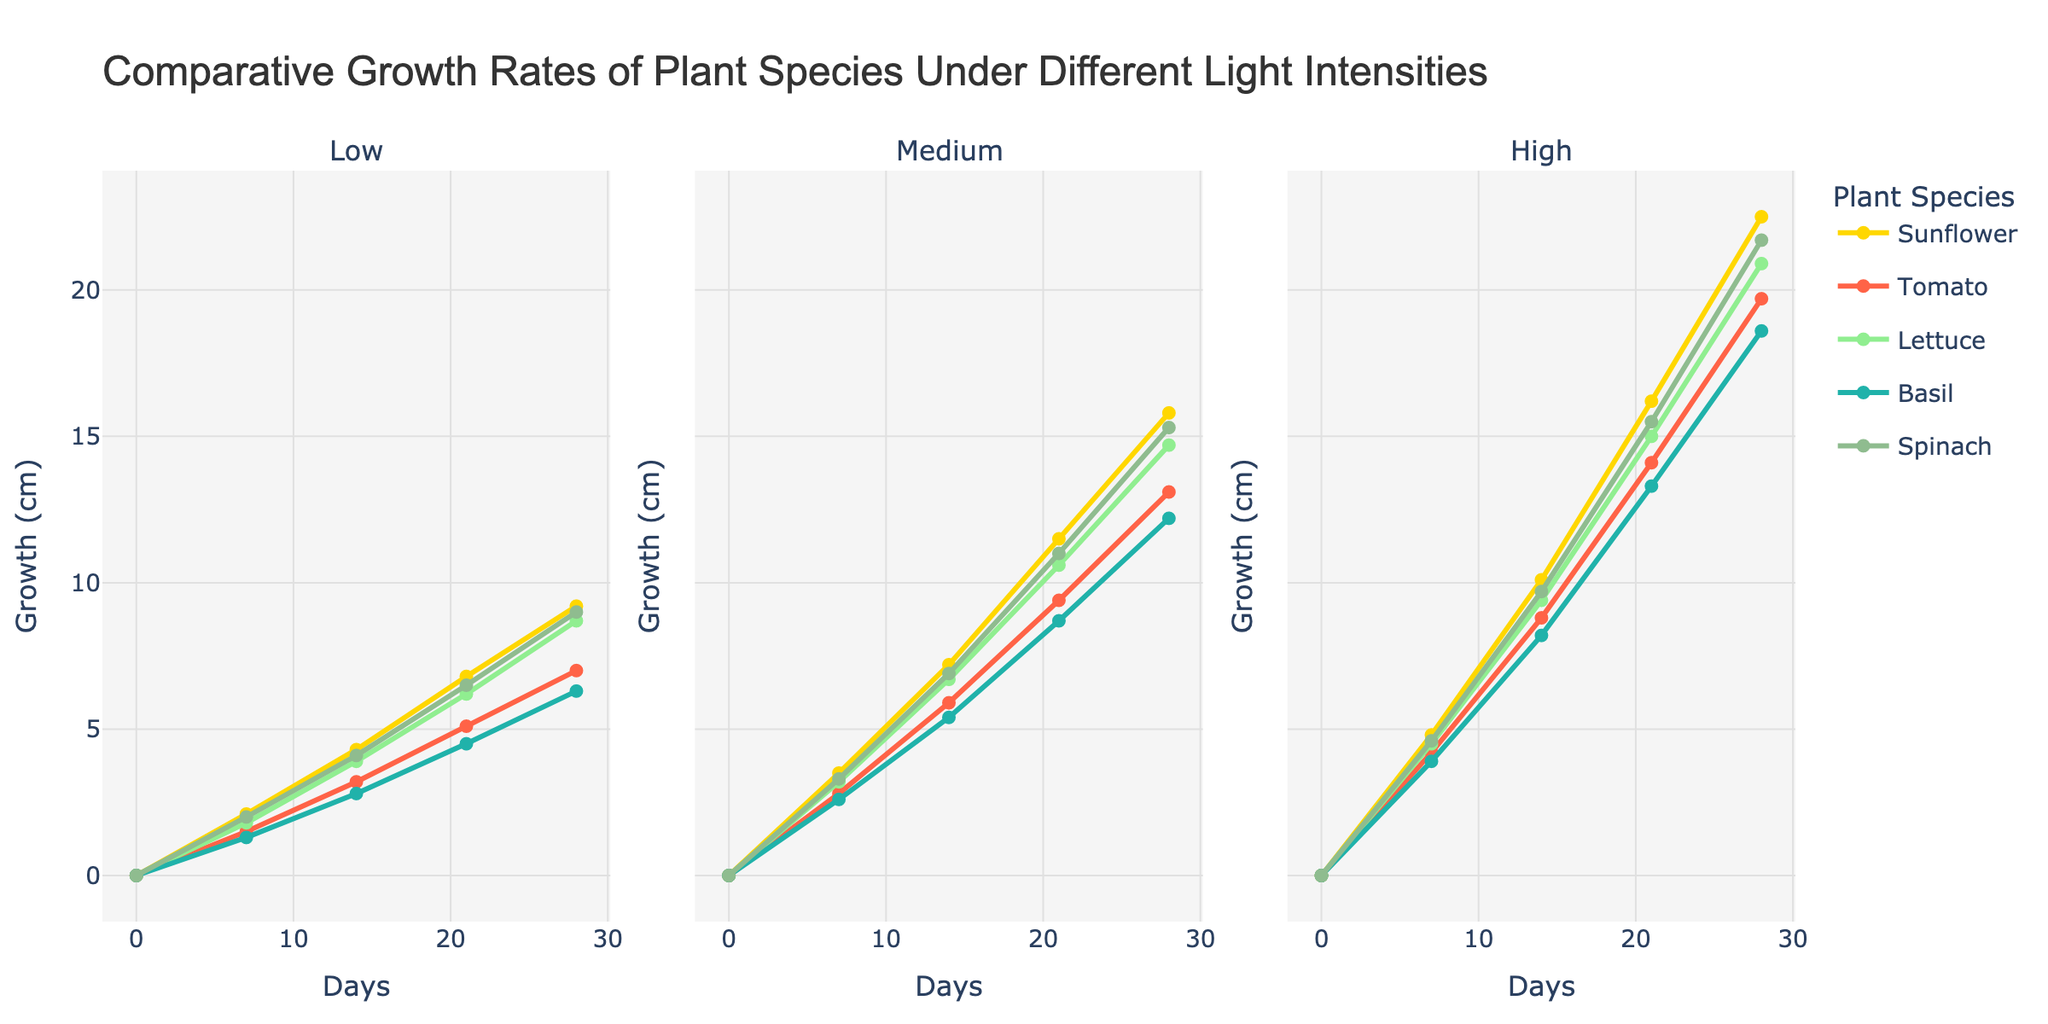which platform's post type 'Eco-Friendly Brand Collaboration' has the highest likes? Look at the 'Eco-Friendly Brand Collaboration' post type across all the platforms and compare the 'Likes' values. Pinterest has multiple data points, but we focus on the specific post type.
Answer: Instagram What is the total number of comments for Facebook posts? Sum up the 'Comments' for all Facebook posts. The values are 75, 58, 92, and 47: \(75 + 58 + 92 + 47 = 272\).
Answer: 272 Which platform has the least number of shares for 'Recycled Packaging Initiative'? Look specifically at the 'Recycled Packaging Initiative' post type across all platforms and compare the 'Shares' values.
Answer: Instagram On which platform does the 'Green Fashion Week Coverage' post type appear, and what are its engagement metrics? Identify the platform displaying 'Green Fashion Week Coverage' then list its 'Likes', 'Comments', and 'Shares'. The platform is Twitter with 380 Likes, 22 Comments, and 145 Shares.
Answer: Twitter: 380 Likes, 22 Comments, 145 Shares Which Facebook post type has the lowest number of likes and what is its number? Look at the 'Likes' values for all Facebook post types and identify the post type with the smallest number.
Answer: Eco-Friendly Accessory Line with 650 Likes Which Twitter post type has the most shares, and how many shares does it have? Compare the 'Shares' value for all Twitter post types to find the highest value.
Answer: Ethical Manufacturing Process with 210 Shares What is the range of likes for Instagram posts? Identify the minimum and maximum 'Likes' values for Instagram posts and subtract the smallest from the largest. The values are 720 and 1560, so \(1560 - 720 = 840\).
Answer: 840 Across which platform do eco-friendly fashion posts generate the most engagement in terms of likes, and which post type contributes to this? Calculate the total 'Likes' for each platform's post types and find the maximum. Pinterest's 'Green Fashion Inspiration Board' with 2100 Likes stands out.
Answer: Pinterest: Green Fashion Inspiration Board What is the average number of shares for Pinterest posts? Sum up all 'Shares' values for Pinterest posts and divide by the number of posts. The total is \(580 + 420 + 710 + 510 = 2220\) and average \(\frac{2220}{4} = 555\).
Answer: 555 